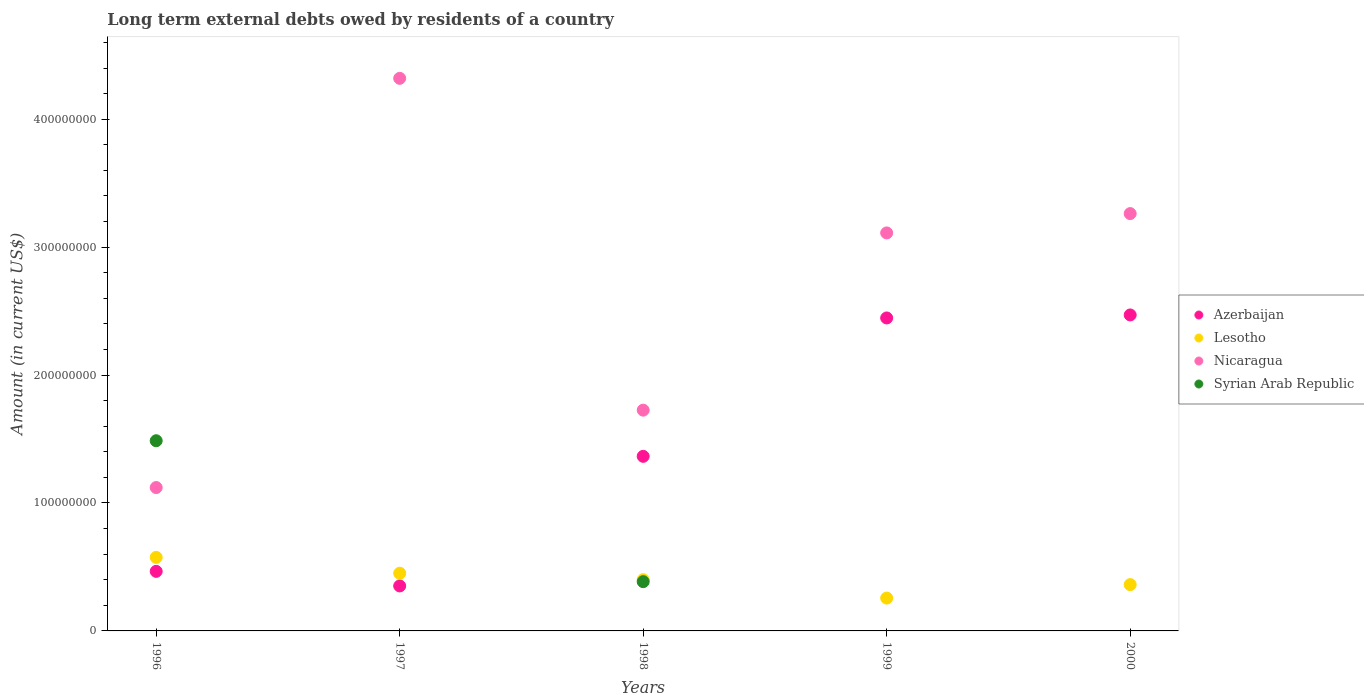How many different coloured dotlines are there?
Offer a terse response. 4. Is the number of dotlines equal to the number of legend labels?
Provide a short and direct response. No. What is the amount of long-term external debts owed by residents in Azerbaijan in 1998?
Offer a terse response. 1.36e+08. Across all years, what is the maximum amount of long-term external debts owed by residents in Nicaragua?
Give a very brief answer. 4.32e+08. Across all years, what is the minimum amount of long-term external debts owed by residents in Nicaragua?
Keep it short and to the point. 1.12e+08. In which year was the amount of long-term external debts owed by residents in Lesotho maximum?
Offer a terse response. 1996. What is the total amount of long-term external debts owed by residents in Nicaragua in the graph?
Make the answer very short. 1.35e+09. What is the difference between the amount of long-term external debts owed by residents in Lesotho in 1996 and that in 2000?
Your answer should be very brief. 2.13e+07. What is the difference between the amount of long-term external debts owed by residents in Lesotho in 1999 and the amount of long-term external debts owed by residents in Azerbaijan in 1996?
Give a very brief answer. -2.09e+07. What is the average amount of long-term external debts owed by residents in Nicaragua per year?
Make the answer very short. 2.71e+08. In the year 1998, what is the difference between the amount of long-term external debts owed by residents in Lesotho and amount of long-term external debts owed by residents in Nicaragua?
Offer a very short reply. -1.33e+08. In how many years, is the amount of long-term external debts owed by residents in Lesotho greater than 140000000 US$?
Your response must be concise. 0. What is the ratio of the amount of long-term external debts owed by residents in Nicaragua in 1996 to that in 1999?
Offer a very short reply. 0.36. What is the difference between the highest and the second highest amount of long-term external debts owed by residents in Lesotho?
Provide a short and direct response. 1.24e+07. What is the difference between the highest and the lowest amount of long-term external debts owed by residents in Syrian Arab Republic?
Keep it short and to the point. 1.49e+08. Is the amount of long-term external debts owed by residents in Lesotho strictly greater than the amount of long-term external debts owed by residents in Syrian Arab Republic over the years?
Ensure brevity in your answer.  No. How many dotlines are there?
Your response must be concise. 4. How many years are there in the graph?
Keep it short and to the point. 5. Are the values on the major ticks of Y-axis written in scientific E-notation?
Provide a succinct answer. No. How many legend labels are there?
Your response must be concise. 4. How are the legend labels stacked?
Offer a terse response. Vertical. What is the title of the graph?
Offer a very short reply. Long term external debts owed by residents of a country. Does "Cyprus" appear as one of the legend labels in the graph?
Keep it short and to the point. No. What is the Amount (in current US$) in Azerbaijan in 1996?
Your answer should be very brief. 4.66e+07. What is the Amount (in current US$) of Lesotho in 1996?
Provide a succinct answer. 5.75e+07. What is the Amount (in current US$) in Nicaragua in 1996?
Your answer should be very brief. 1.12e+08. What is the Amount (in current US$) of Syrian Arab Republic in 1996?
Provide a succinct answer. 1.49e+08. What is the Amount (in current US$) of Azerbaijan in 1997?
Offer a terse response. 3.52e+07. What is the Amount (in current US$) in Lesotho in 1997?
Make the answer very short. 4.51e+07. What is the Amount (in current US$) of Nicaragua in 1997?
Offer a terse response. 4.32e+08. What is the Amount (in current US$) in Syrian Arab Republic in 1997?
Provide a short and direct response. 0. What is the Amount (in current US$) of Azerbaijan in 1998?
Provide a succinct answer. 1.36e+08. What is the Amount (in current US$) in Lesotho in 1998?
Give a very brief answer. 4.00e+07. What is the Amount (in current US$) in Nicaragua in 1998?
Keep it short and to the point. 1.73e+08. What is the Amount (in current US$) in Syrian Arab Republic in 1998?
Your response must be concise. 3.85e+07. What is the Amount (in current US$) in Azerbaijan in 1999?
Provide a short and direct response. 2.45e+08. What is the Amount (in current US$) of Lesotho in 1999?
Make the answer very short. 2.57e+07. What is the Amount (in current US$) in Nicaragua in 1999?
Your answer should be very brief. 3.11e+08. What is the Amount (in current US$) in Azerbaijan in 2000?
Ensure brevity in your answer.  2.47e+08. What is the Amount (in current US$) in Lesotho in 2000?
Provide a succinct answer. 3.62e+07. What is the Amount (in current US$) of Nicaragua in 2000?
Offer a very short reply. 3.26e+08. Across all years, what is the maximum Amount (in current US$) in Azerbaijan?
Your response must be concise. 2.47e+08. Across all years, what is the maximum Amount (in current US$) of Lesotho?
Provide a short and direct response. 5.75e+07. Across all years, what is the maximum Amount (in current US$) in Nicaragua?
Offer a terse response. 4.32e+08. Across all years, what is the maximum Amount (in current US$) of Syrian Arab Republic?
Your answer should be compact. 1.49e+08. Across all years, what is the minimum Amount (in current US$) of Azerbaijan?
Ensure brevity in your answer.  3.52e+07. Across all years, what is the minimum Amount (in current US$) in Lesotho?
Provide a short and direct response. 2.57e+07. Across all years, what is the minimum Amount (in current US$) in Nicaragua?
Give a very brief answer. 1.12e+08. What is the total Amount (in current US$) in Azerbaijan in the graph?
Offer a terse response. 7.10e+08. What is the total Amount (in current US$) in Lesotho in the graph?
Provide a succinct answer. 2.05e+08. What is the total Amount (in current US$) in Nicaragua in the graph?
Offer a terse response. 1.35e+09. What is the total Amount (in current US$) of Syrian Arab Republic in the graph?
Your response must be concise. 1.87e+08. What is the difference between the Amount (in current US$) of Azerbaijan in 1996 and that in 1997?
Your response must be concise. 1.14e+07. What is the difference between the Amount (in current US$) of Lesotho in 1996 and that in 1997?
Offer a terse response. 1.24e+07. What is the difference between the Amount (in current US$) of Nicaragua in 1996 and that in 1997?
Your answer should be compact. -3.20e+08. What is the difference between the Amount (in current US$) of Azerbaijan in 1996 and that in 1998?
Keep it short and to the point. -8.99e+07. What is the difference between the Amount (in current US$) of Lesotho in 1996 and that in 1998?
Your answer should be compact. 1.74e+07. What is the difference between the Amount (in current US$) of Nicaragua in 1996 and that in 1998?
Your answer should be very brief. -6.05e+07. What is the difference between the Amount (in current US$) of Syrian Arab Republic in 1996 and that in 1998?
Provide a succinct answer. 1.10e+08. What is the difference between the Amount (in current US$) of Azerbaijan in 1996 and that in 1999?
Keep it short and to the point. -1.98e+08. What is the difference between the Amount (in current US$) of Lesotho in 1996 and that in 1999?
Provide a succinct answer. 3.18e+07. What is the difference between the Amount (in current US$) in Nicaragua in 1996 and that in 1999?
Your answer should be very brief. -1.99e+08. What is the difference between the Amount (in current US$) in Azerbaijan in 1996 and that in 2000?
Offer a very short reply. -2.00e+08. What is the difference between the Amount (in current US$) in Lesotho in 1996 and that in 2000?
Offer a very short reply. 2.13e+07. What is the difference between the Amount (in current US$) in Nicaragua in 1996 and that in 2000?
Your response must be concise. -2.14e+08. What is the difference between the Amount (in current US$) of Azerbaijan in 1997 and that in 1998?
Provide a short and direct response. -1.01e+08. What is the difference between the Amount (in current US$) in Lesotho in 1997 and that in 1998?
Give a very brief answer. 5.08e+06. What is the difference between the Amount (in current US$) of Nicaragua in 1997 and that in 1998?
Give a very brief answer. 2.59e+08. What is the difference between the Amount (in current US$) in Azerbaijan in 1997 and that in 1999?
Make the answer very short. -2.09e+08. What is the difference between the Amount (in current US$) in Lesotho in 1997 and that in 1999?
Keep it short and to the point. 1.94e+07. What is the difference between the Amount (in current US$) in Nicaragua in 1997 and that in 1999?
Provide a succinct answer. 1.21e+08. What is the difference between the Amount (in current US$) of Azerbaijan in 1997 and that in 2000?
Your answer should be compact. -2.12e+08. What is the difference between the Amount (in current US$) in Lesotho in 1997 and that in 2000?
Your response must be concise. 8.91e+06. What is the difference between the Amount (in current US$) of Nicaragua in 1997 and that in 2000?
Your response must be concise. 1.06e+08. What is the difference between the Amount (in current US$) of Azerbaijan in 1998 and that in 1999?
Your response must be concise. -1.08e+08. What is the difference between the Amount (in current US$) of Lesotho in 1998 and that in 1999?
Provide a short and direct response. 1.43e+07. What is the difference between the Amount (in current US$) of Nicaragua in 1998 and that in 1999?
Your answer should be compact. -1.39e+08. What is the difference between the Amount (in current US$) in Azerbaijan in 1998 and that in 2000?
Make the answer very short. -1.11e+08. What is the difference between the Amount (in current US$) in Lesotho in 1998 and that in 2000?
Provide a short and direct response. 3.83e+06. What is the difference between the Amount (in current US$) of Nicaragua in 1998 and that in 2000?
Give a very brief answer. -1.54e+08. What is the difference between the Amount (in current US$) of Azerbaijan in 1999 and that in 2000?
Keep it short and to the point. -2.35e+06. What is the difference between the Amount (in current US$) of Lesotho in 1999 and that in 2000?
Give a very brief answer. -1.05e+07. What is the difference between the Amount (in current US$) in Nicaragua in 1999 and that in 2000?
Offer a very short reply. -1.51e+07. What is the difference between the Amount (in current US$) of Azerbaijan in 1996 and the Amount (in current US$) of Lesotho in 1997?
Offer a terse response. 1.44e+06. What is the difference between the Amount (in current US$) of Azerbaijan in 1996 and the Amount (in current US$) of Nicaragua in 1997?
Offer a very short reply. -3.85e+08. What is the difference between the Amount (in current US$) in Lesotho in 1996 and the Amount (in current US$) in Nicaragua in 1997?
Your response must be concise. -3.74e+08. What is the difference between the Amount (in current US$) of Azerbaijan in 1996 and the Amount (in current US$) of Lesotho in 1998?
Your response must be concise. 6.53e+06. What is the difference between the Amount (in current US$) in Azerbaijan in 1996 and the Amount (in current US$) in Nicaragua in 1998?
Offer a very short reply. -1.26e+08. What is the difference between the Amount (in current US$) of Azerbaijan in 1996 and the Amount (in current US$) of Syrian Arab Republic in 1998?
Your response must be concise. 8.05e+06. What is the difference between the Amount (in current US$) of Lesotho in 1996 and the Amount (in current US$) of Nicaragua in 1998?
Keep it short and to the point. -1.15e+08. What is the difference between the Amount (in current US$) of Lesotho in 1996 and the Amount (in current US$) of Syrian Arab Republic in 1998?
Your response must be concise. 1.90e+07. What is the difference between the Amount (in current US$) of Nicaragua in 1996 and the Amount (in current US$) of Syrian Arab Republic in 1998?
Offer a very short reply. 7.36e+07. What is the difference between the Amount (in current US$) of Azerbaijan in 1996 and the Amount (in current US$) of Lesotho in 1999?
Provide a succinct answer. 2.09e+07. What is the difference between the Amount (in current US$) of Azerbaijan in 1996 and the Amount (in current US$) of Nicaragua in 1999?
Provide a succinct answer. -2.65e+08. What is the difference between the Amount (in current US$) in Lesotho in 1996 and the Amount (in current US$) in Nicaragua in 1999?
Offer a very short reply. -2.54e+08. What is the difference between the Amount (in current US$) in Azerbaijan in 1996 and the Amount (in current US$) in Lesotho in 2000?
Your answer should be compact. 1.04e+07. What is the difference between the Amount (in current US$) in Azerbaijan in 1996 and the Amount (in current US$) in Nicaragua in 2000?
Your response must be concise. -2.80e+08. What is the difference between the Amount (in current US$) in Lesotho in 1996 and the Amount (in current US$) in Nicaragua in 2000?
Your answer should be very brief. -2.69e+08. What is the difference between the Amount (in current US$) of Azerbaijan in 1997 and the Amount (in current US$) of Lesotho in 1998?
Keep it short and to the point. -4.87e+06. What is the difference between the Amount (in current US$) in Azerbaijan in 1997 and the Amount (in current US$) in Nicaragua in 1998?
Provide a succinct answer. -1.37e+08. What is the difference between the Amount (in current US$) in Azerbaijan in 1997 and the Amount (in current US$) in Syrian Arab Republic in 1998?
Offer a very short reply. -3.35e+06. What is the difference between the Amount (in current US$) in Lesotho in 1997 and the Amount (in current US$) in Nicaragua in 1998?
Your answer should be compact. -1.27e+08. What is the difference between the Amount (in current US$) of Lesotho in 1997 and the Amount (in current US$) of Syrian Arab Republic in 1998?
Your answer should be compact. 6.60e+06. What is the difference between the Amount (in current US$) of Nicaragua in 1997 and the Amount (in current US$) of Syrian Arab Republic in 1998?
Provide a succinct answer. 3.93e+08. What is the difference between the Amount (in current US$) of Azerbaijan in 1997 and the Amount (in current US$) of Lesotho in 1999?
Your response must be concise. 9.48e+06. What is the difference between the Amount (in current US$) in Azerbaijan in 1997 and the Amount (in current US$) in Nicaragua in 1999?
Your answer should be compact. -2.76e+08. What is the difference between the Amount (in current US$) of Lesotho in 1997 and the Amount (in current US$) of Nicaragua in 1999?
Your answer should be compact. -2.66e+08. What is the difference between the Amount (in current US$) in Azerbaijan in 1997 and the Amount (in current US$) in Lesotho in 2000?
Provide a short and direct response. -1.04e+06. What is the difference between the Amount (in current US$) of Azerbaijan in 1997 and the Amount (in current US$) of Nicaragua in 2000?
Ensure brevity in your answer.  -2.91e+08. What is the difference between the Amount (in current US$) in Lesotho in 1997 and the Amount (in current US$) in Nicaragua in 2000?
Provide a short and direct response. -2.81e+08. What is the difference between the Amount (in current US$) in Azerbaijan in 1998 and the Amount (in current US$) in Lesotho in 1999?
Keep it short and to the point. 1.11e+08. What is the difference between the Amount (in current US$) in Azerbaijan in 1998 and the Amount (in current US$) in Nicaragua in 1999?
Offer a terse response. -1.75e+08. What is the difference between the Amount (in current US$) of Lesotho in 1998 and the Amount (in current US$) of Nicaragua in 1999?
Offer a very short reply. -2.71e+08. What is the difference between the Amount (in current US$) in Azerbaijan in 1998 and the Amount (in current US$) in Lesotho in 2000?
Give a very brief answer. 1.00e+08. What is the difference between the Amount (in current US$) in Azerbaijan in 1998 and the Amount (in current US$) in Nicaragua in 2000?
Offer a very short reply. -1.90e+08. What is the difference between the Amount (in current US$) of Lesotho in 1998 and the Amount (in current US$) of Nicaragua in 2000?
Your response must be concise. -2.86e+08. What is the difference between the Amount (in current US$) of Azerbaijan in 1999 and the Amount (in current US$) of Lesotho in 2000?
Your answer should be very brief. 2.08e+08. What is the difference between the Amount (in current US$) of Azerbaijan in 1999 and the Amount (in current US$) of Nicaragua in 2000?
Offer a very short reply. -8.16e+07. What is the difference between the Amount (in current US$) of Lesotho in 1999 and the Amount (in current US$) of Nicaragua in 2000?
Keep it short and to the point. -3.01e+08. What is the average Amount (in current US$) of Azerbaijan per year?
Provide a short and direct response. 1.42e+08. What is the average Amount (in current US$) of Lesotho per year?
Ensure brevity in your answer.  4.09e+07. What is the average Amount (in current US$) in Nicaragua per year?
Make the answer very short. 2.71e+08. What is the average Amount (in current US$) in Syrian Arab Republic per year?
Make the answer very short. 3.74e+07. In the year 1996, what is the difference between the Amount (in current US$) of Azerbaijan and Amount (in current US$) of Lesotho?
Give a very brief answer. -1.09e+07. In the year 1996, what is the difference between the Amount (in current US$) of Azerbaijan and Amount (in current US$) of Nicaragua?
Keep it short and to the point. -6.55e+07. In the year 1996, what is the difference between the Amount (in current US$) of Azerbaijan and Amount (in current US$) of Syrian Arab Republic?
Ensure brevity in your answer.  -1.02e+08. In the year 1996, what is the difference between the Amount (in current US$) of Lesotho and Amount (in current US$) of Nicaragua?
Offer a very short reply. -5.46e+07. In the year 1996, what is the difference between the Amount (in current US$) in Lesotho and Amount (in current US$) in Syrian Arab Republic?
Give a very brief answer. -9.12e+07. In the year 1996, what is the difference between the Amount (in current US$) of Nicaragua and Amount (in current US$) of Syrian Arab Republic?
Provide a short and direct response. -3.66e+07. In the year 1997, what is the difference between the Amount (in current US$) in Azerbaijan and Amount (in current US$) in Lesotho?
Your answer should be very brief. -9.95e+06. In the year 1997, what is the difference between the Amount (in current US$) of Azerbaijan and Amount (in current US$) of Nicaragua?
Offer a terse response. -3.97e+08. In the year 1997, what is the difference between the Amount (in current US$) in Lesotho and Amount (in current US$) in Nicaragua?
Offer a terse response. -3.87e+08. In the year 1998, what is the difference between the Amount (in current US$) of Azerbaijan and Amount (in current US$) of Lesotho?
Your response must be concise. 9.64e+07. In the year 1998, what is the difference between the Amount (in current US$) in Azerbaijan and Amount (in current US$) in Nicaragua?
Provide a succinct answer. -3.61e+07. In the year 1998, what is the difference between the Amount (in current US$) in Azerbaijan and Amount (in current US$) in Syrian Arab Republic?
Your answer should be very brief. 9.80e+07. In the year 1998, what is the difference between the Amount (in current US$) in Lesotho and Amount (in current US$) in Nicaragua?
Provide a short and direct response. -1.33e+08. In the year 1998, what is the difference between the Amount (in current US$) of Lesotho and Amount (in current US$) of Syrian Arab Republic?
Offer a very short reply. 1.52e+06. In the year 1998, what is the difference between the Amount (in current US$) in Nicaragua and Amount (in current US$) in Syrian Arab Republic?
Your response must be concise. 1.34e+08. In the year 1999, what is the difference between the Amount (in current US$) of Azerbaijan and Amount (in current US$) of Lesotho?
Provide a succinct answer. 2.19e+08. In the year 1999, what is the difference between the Amount (in current US$) in Azerbaijan and Amount (in current US$) in Nicaragua?
Give a very brief answer. -6.65e+07. In the year 1999, what is the difference between the Amount (in current US$) in Lesotho and Amount (in current US$) in Nicaragua?
Your answer should be compact. -2.85e+08. In the year 2000, what is the difference between the Amount (in current US$) of Azerbaijan and Amount (in current US$) of Lesotho?
Ensure brevity in your answer.  2.11e+08. In the year 2000, what is the difference between the Amount (in current US$) of Azerbaijan and Amount (in current US$) of Nicaragua?
Offer a very short reply. -7.92e+07. In the year 2000, what is the difference between the Amount (in current US$) of Lesotho and Amount (in current US$) of Nicaragua?
Give a very brief answer. -2.90e+08. What is the ratio of the Amount (in current US$) of Azerbaijan in 1996 to that in 1997?
Offer a very short reply. 1.32. What is the ratio of the Amount (in current US$) in Lesotho in 1996 to that in 1997?
Offer a terse response. 1.27. What is the ratio of the Amount (in current US$) of Nicaragua in 1996 to that in 1997?
Provide a succinct answer. 0.26. What is the ratio of the Amount (in current US$) of Azerbaijan in 1996 to that in 1998?
Your answer should be compact. 0.34. What is the ratio of the Amount (in current US$) of Lesotho in 1996 to that in 1998?
Ensure brevity in your answer.  1.44. What is the ratio of the Amount (in current US$) in Nicaragua in 1996 to that in 1998?
Ensure brevity in your answer.  0.65. What is the ratio of the Amount (in current US$) of Syrian Arab Republic in 1996 to that in 1998?
Offer a very short reply. 3.86. What is the ratio of the Amount (in current US$) in Azerbaijan in 1996 to that in 1999?
Keep it short and to the point. 0.19. What is the ratio of the Amount (in current US$) in Lesotho in 1996 to that in 1999?
Your answer should be compact. 2.24. What is the ratio of the Amount (in current US$) of Nicaragua in 1996 to that in 1999?
Give a very brief answer. 0.36. What is the ratio of the Amount (in current US$) of Azerbaijan in 1996 to that in 2000?
Keep it short and to the point. 0.19. What is the ratio of the Amount (in current US$) in Lesotho in 1996 to that in 2000?
Your response must be concise. 1.59. What is the ratio of the Amount (in current US$) of Nicaragua in 1996 to that in 2000?
Provide a succinct answer. 0.34. What is the ratio of the Amount (in current US$) in Azerbaijan in 1997 to that in 1998?
Give a very brief answer. 0.26. What is the ratio of the Amount (in current US$) of Lesotho in 1997 to that in 1998?
Provide a short and direct response. 1.13. What is the ratio of the Amount (in current US$) in Nicaragua in 1997 to that in 1998?
Your response must be concise. 2.5. What is the ratio of the Amount (in current US$) of Azerbaijan in 1997 to that in 1999?
Give a very brief answer. 0.14. What is the ratio of the Amount (in current US$) in Lesotho in 1997 to that in 1999?
Your response must be concise. 1.76. What is the ratio of the Amount (in current US$) in Nicaragua in 1997 to that in 1999?
Your answer should be compact. 1.39. What is the ratio of the Amount (in current US$) of Azerbaijan in 1997 to that in 2000?
Provide a short and direct response. 0.14. What is the ratio of the Amount (in current US$) of Lesotho in 1997 to that in 2000?
Your answer should be compact. 1.25. What is the ratio of the Amount (in current US$) in Nicaragua in 1997 to that in 2000?
Ensure brevity in your answer.  1.32. What is the ratio of the Amount (in current US$) in Azerbaijan in 1998 to that in 1999?
Your answer should be very brief. 0.56. What is the ratio of the Amount (in current US$) of Lesotho in 1998 to that in 1999?
Your response must be concise. 1.56. What is the ratio of the Amount (in current US$) in Nicaragua in 1998 to that in 1999?
Offer a terse response. 0.55. What is the ratio of the Amount (in current US$) of Azerbaijan in 1998 to that in 2000?
Your answer should be very brief. 0.55. What is the ratio of the Amount (in current US$) in Lesotho in 1998 to that in 2000?
Give a very brief answer. 1.11. What is the ratio of the Amount (in current US$) in Nicaragua in 1998 to that in 2000?
Provide a succinct answer. 0.53. What is the ratio of the Amount (in current US$) of Lesotho in 1999 to that in 2000?
Your answer should be compact. 0.71. What is the ratio of the Amount (in current US$) of Nicaragua in 1999 to that in 2000?
Offer a terse response. 0.95. What is the difference between the highest and the second highest Amount (in current US$) in Azerbaijan?
Make the answer very short. 2.35e+06. What is the difference between the highest and the second highest Amount (in current US$) of Lesotho?
Your answer should be compact. 1.24e+07. What is the difference between the highest and the second highest Amount (in current US$) of Nicaragua?
Your response must be concise. 1.06e+08. What is the difference between the highest and the lowest Amount (in current US$) in Azerbaijan?
Keep it short and to the point. 2.12e+08. What is the difference between the highest and the lowest Amount (in current US$) in Lesotho?
Offer a very short reply. 3.18e+07. What is the difference between the highest and the lowest Amount (in current US$) of Nicaragua?
Your answer should be compact. 3.20e+08. What is the difference between the highest and the lowest Amount (in current US$) of Syrian Arab Republic?
Offer a terse response. 1.49e+08. 